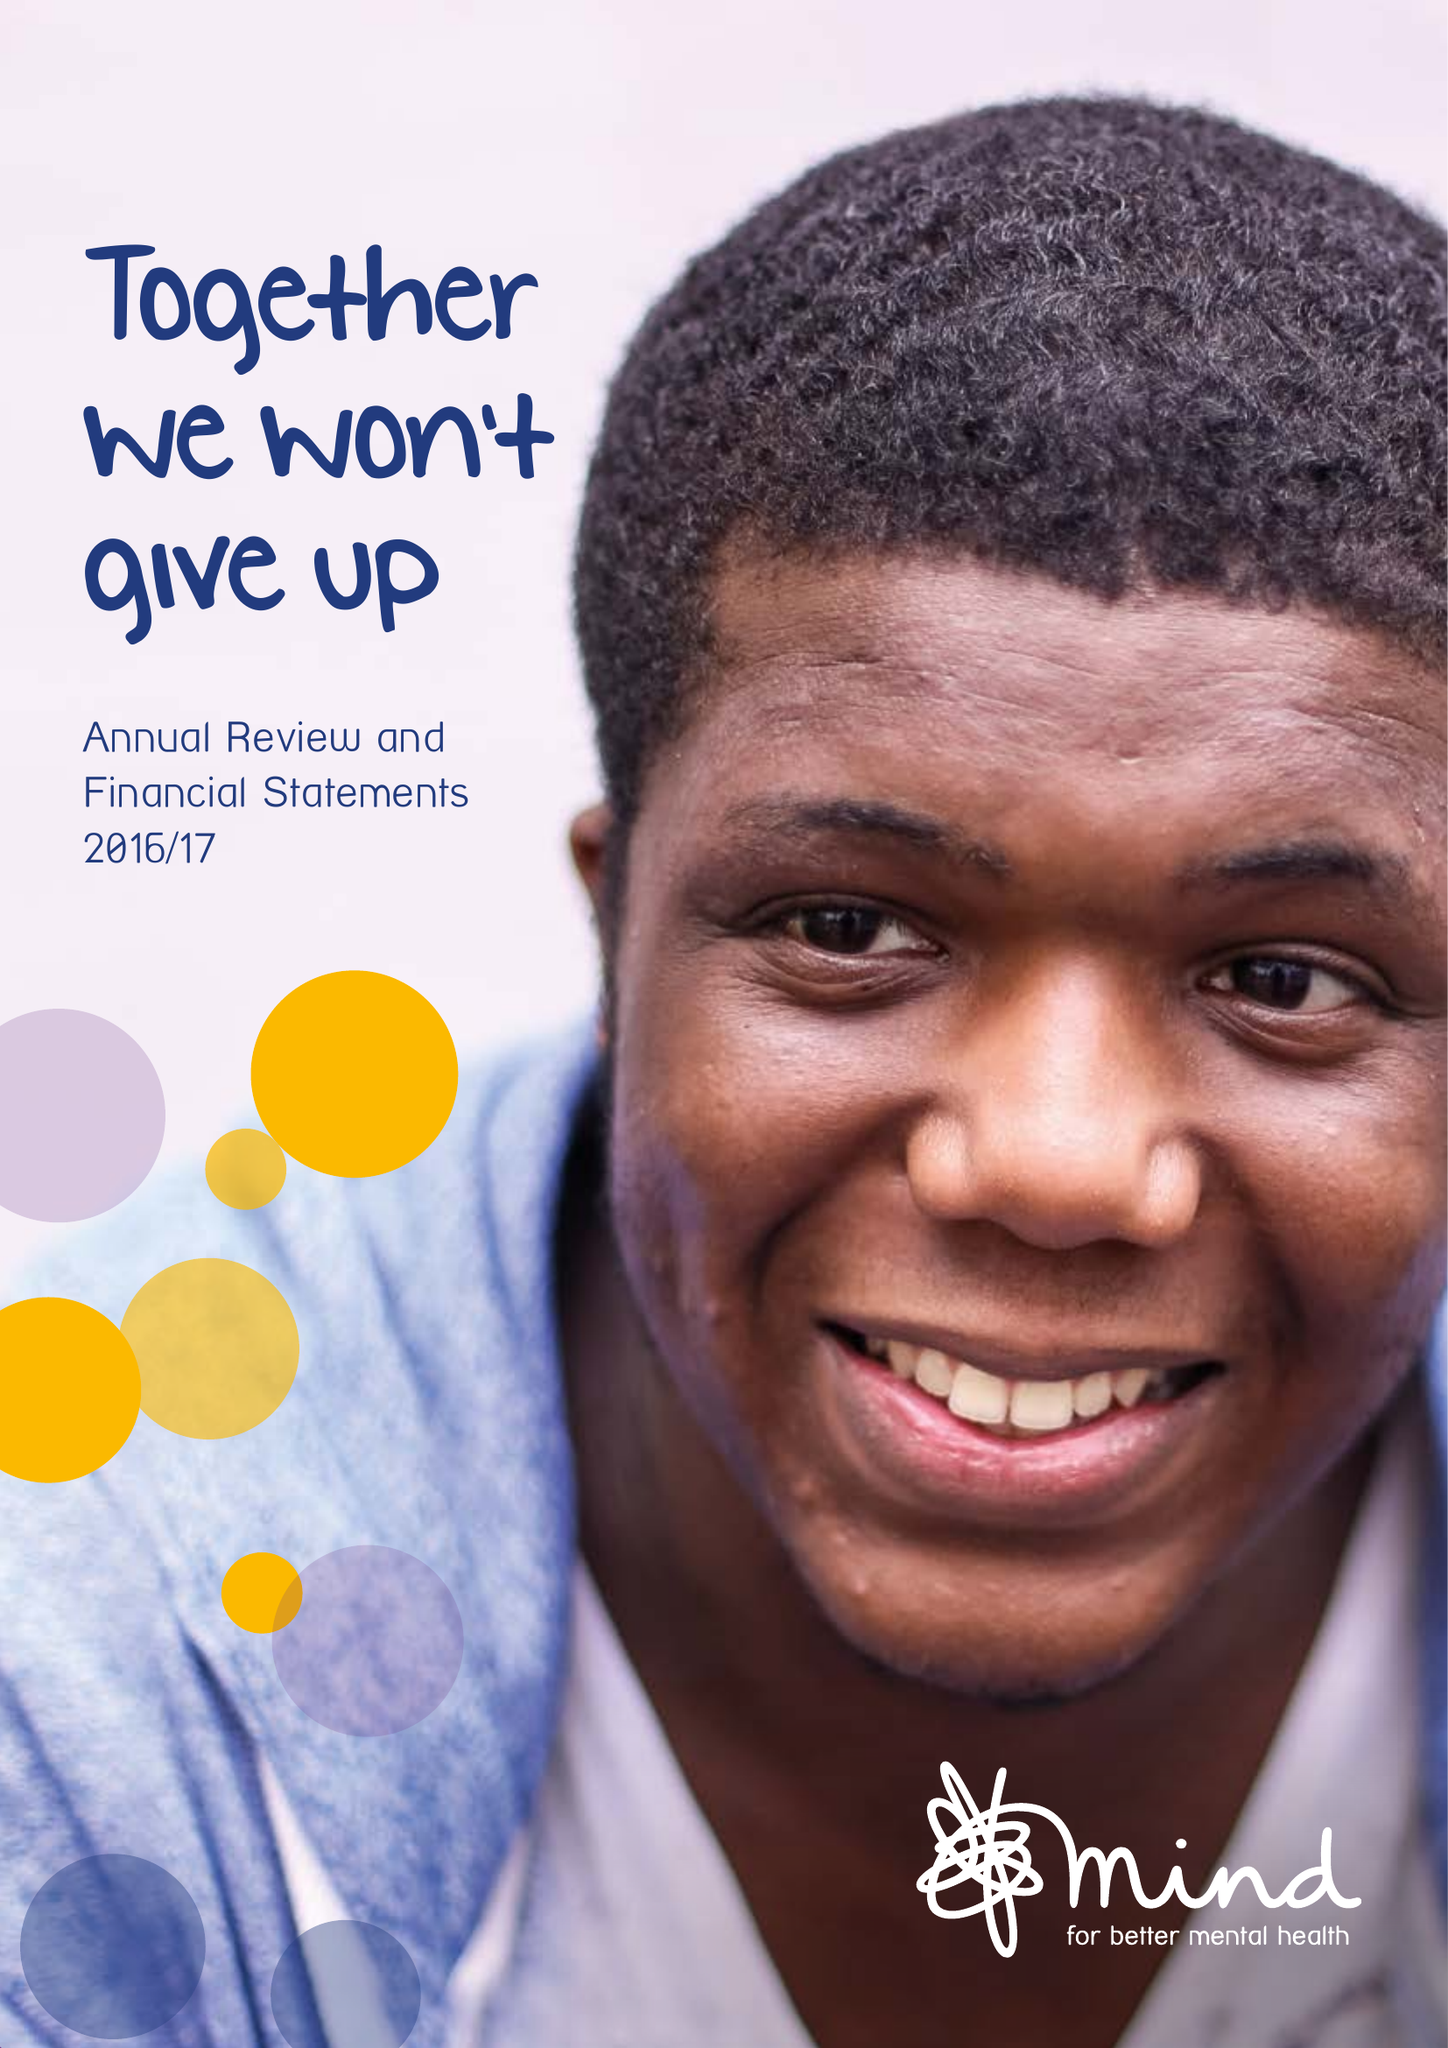What is the value for the income_annually_in_british_pounds?
Answer the question using a single word or phrase. 41329000.00 